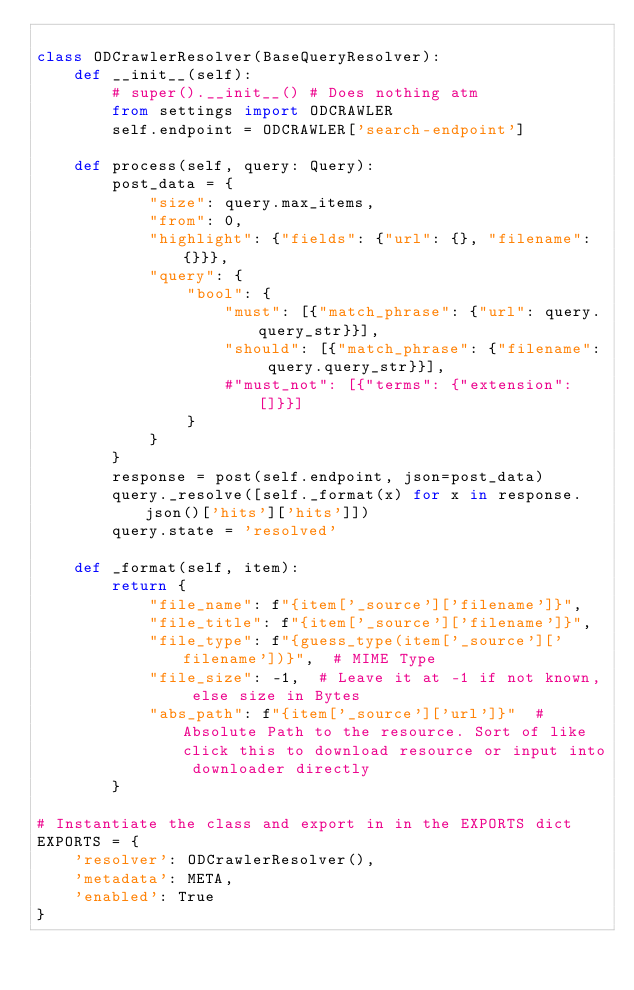<code> <loc_0><loc_0><loc_500><loc_500><_Python_>
class ODCrawlerResolver(BaseQueryResolver):
    def __init__(self):
        # super().__init__() # Does nothing atm
        from settings import ODCRAWLER
        self.endpoint = ODCRAWLER['search-endpoint']

    def process(self, query: Query):
        post_data = {
            "size": query.max_items,
            "from": 0,
            "highlight": {"fields": {"url": {}, "filename": {}}},
            "query": {
                "bool": {
                    "must": [{"match_phrase": {"url": query.query_str}}],
                    "should": [{"match_phrase": {"filename": query.query_str}}],
                    #"must_not": [{"terms": {"extension": []}}]
                }
            }
        }
        response = post(self.endpoint, json=post_data)
        query._resolve([self._format(x) for x in response.json()['hits']['hits']])
        query.state = 'resolved'
        
    def _format(self, item):
        return {
            "file_name": f"{item['_source']['filename']}",
            "file_title": f"{item['_source']['filename']}",
            "file_type": f"{guess_type(item['_source']['filename'])}",  # MIME Type
            "file_size": -1,  # Leave it at -1 if not known, else size in Bytes
            "abs_path": f"{item['_source']['url']}"  # Absolute Path to the resource. Sort of like click this to download resource or input into downloader directly
        }

# Instantiate the class and export in in the EXPORTS dict
EXPORTS = {
    'resolver': ODCrawlerResolver(),
    'metadata': META,
    'enabled': True
}
</code> 